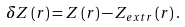<formula> <loc_0><loc_0><loc_500><loc_500>\delta Z \left ( r \right ) = Z \left ( r \right ) - Z _ { e x t r } \left ( r \right ) .</formula> 